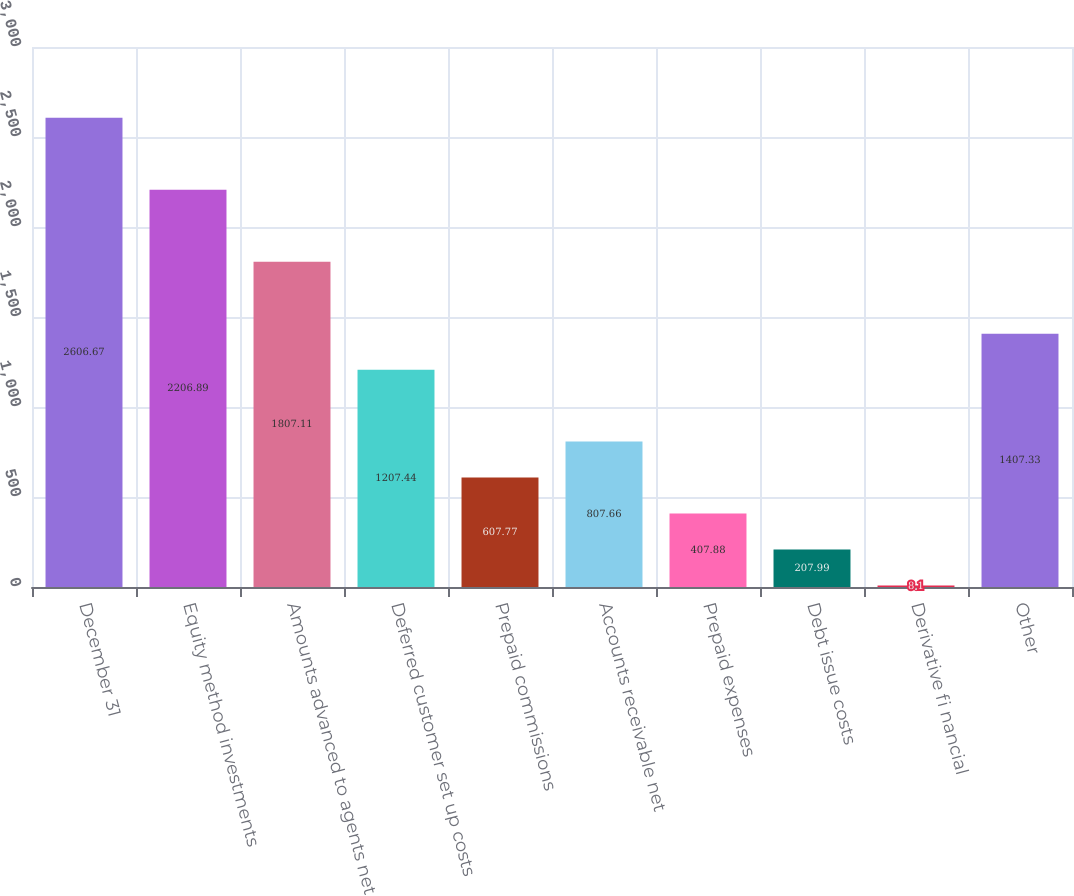Convert chart. <chart><loc_0><loc_0><loc_500><loc_500><bar_chart><fcel>December 31<fcel>Equity method investments<fcel>Amounts advanced to agents net<fcel>Deferred customer set up costs<fcel>Prepaid commissions<fcel>Accounts receivable net<fcel>Prepaid expenses<fcel>Debt issue costs<fcel>Derivative fi nancial<fcel>Other<nl><fcel>2606.67<fcel>2206.89<fcel>1807.11<fcel>1207.44<fcel>607.77<fcel>807.66<fcel>407.88<fcel>207.99<fcel>8.1<fcel>1407.33<nl></chart> 